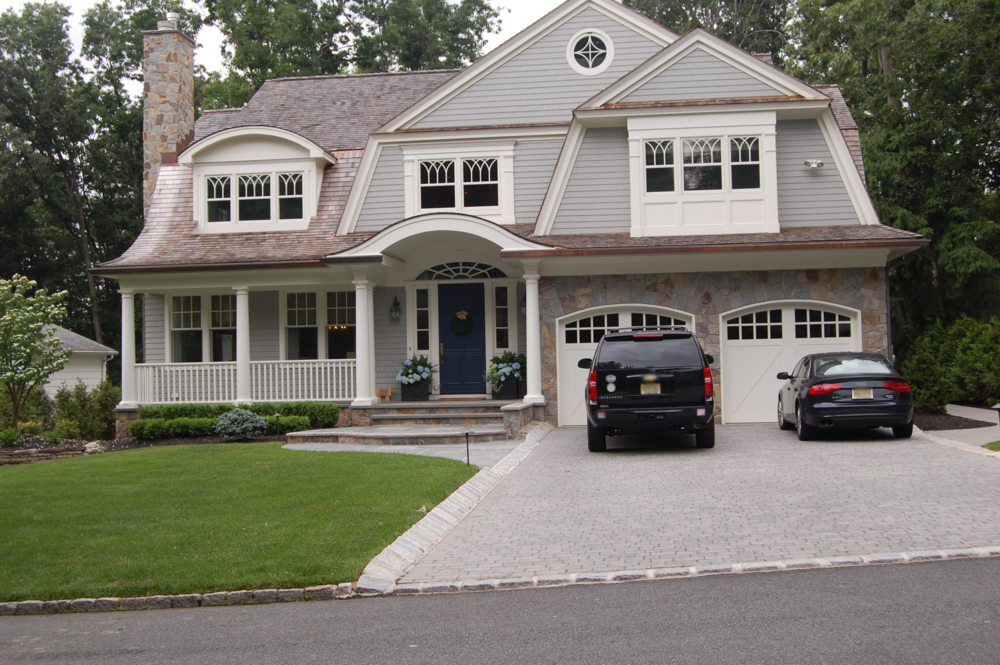What architectural style does the house's design suggest, and how do the vehicles parked in the driveway complement or contrast with this style? The house is predominantly indicative of Craftsman-style architecture, distinguished by its blend of materials such as wood, stone, and brick. Features like the covered front porch supported by columns, the prominent dormer windows, and the unique roofline solidify this identification. The two vehicles in the driveway—a sleek black SUV and a modern sports car—introduce a striking contrast to this aesthetic. While the house exudes a timeless, artisanal charm, the cars embody contemporary design principles, representing modernity’s sleekness and sharpness. This juxtaposition creates an interesting dynamic between the house’s historical style and the vehicles' present-day sophistication, enriching the visual narrative of the scene. 